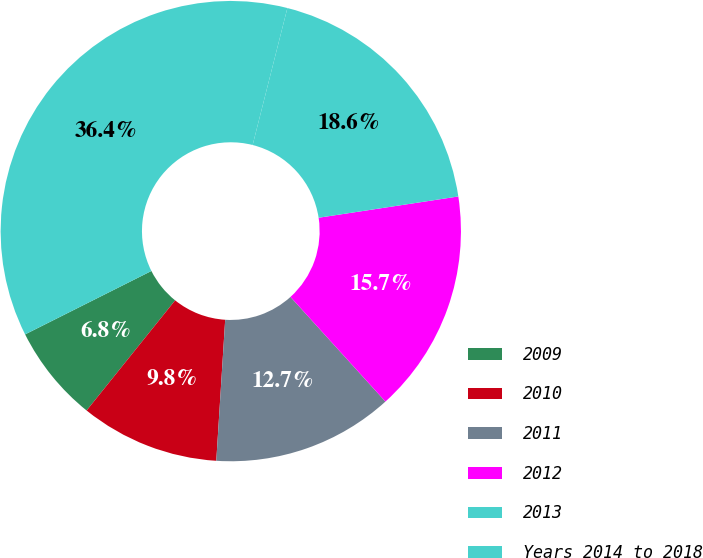<chart> <loc_0><loc_0><loc_500><loc_500><pie_chart><fcel>2009<fcel>2010<fcel>2011<fcel>2012<fcel>2013<fcel>Years 2014 to 2018<nl><fcel>6.82%<fcel>9.77%<fcel>12.73%<fcel>15.68%<fcel>18.64%<fcel>36.36%<nl></chart> 